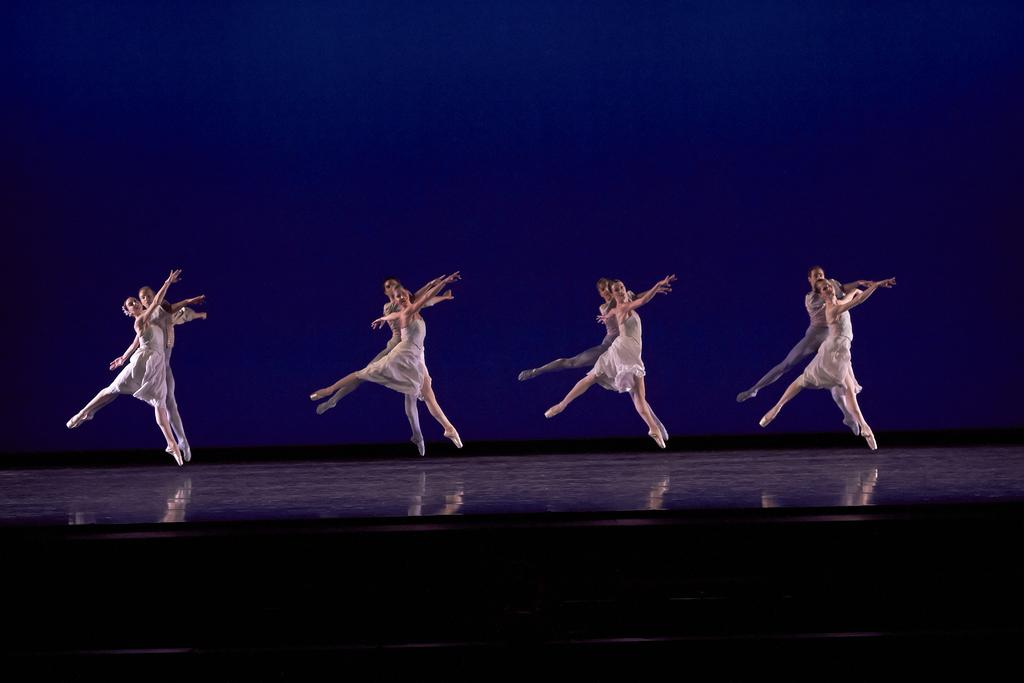Who is present in the image? There are people in the image. What are the people wearing? The people are wearing white dresses. What are the people doing in the image? The people are dancing on a stage. What color is the background in the image? The background in the image is blue. What type of clocks can be seen on the stage in the image? There are no clocks visible in the image; the people are dancing on a stage. Are the people swimming in the image? No, the people are not swimming in the image; they are dancing on a stage. 